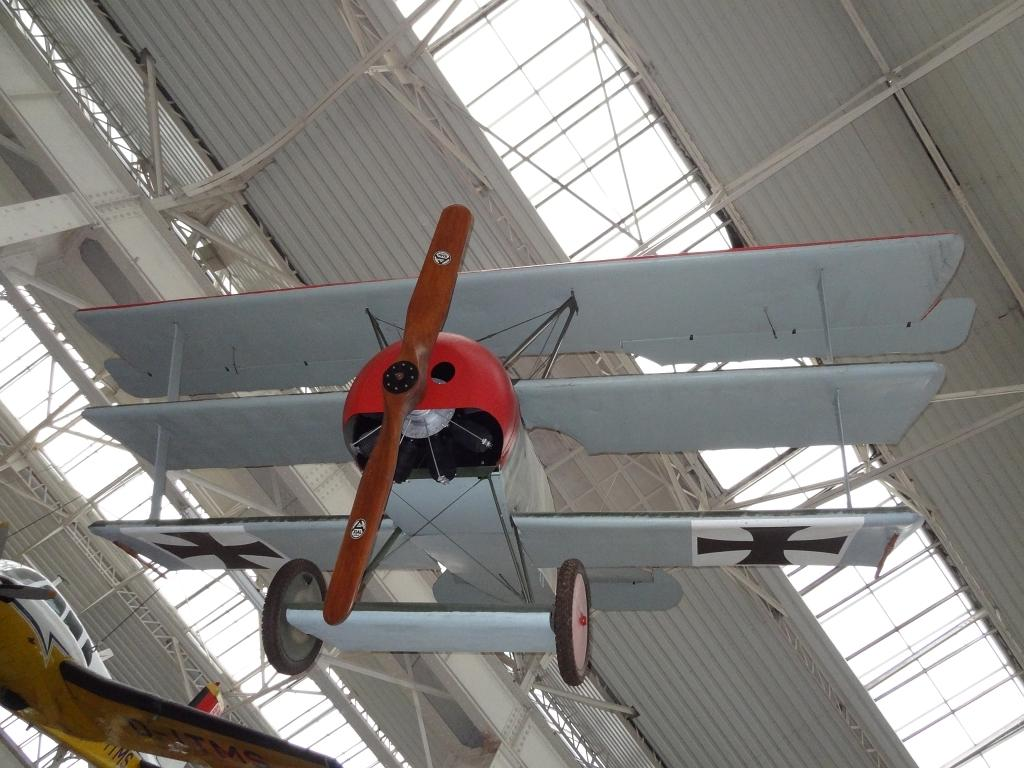How many airplanes are visible in the image? There are two airplanes in the image. What type of structure can be seen in the image? There is a metal shed in the image. How is the metal shed supported? The metal shed is supported by metal rod pillars. How many boats are visible in the image? There are no boats visible in the image; it only features two airplanes and a metal shed. Can you spot a crow perched on one of the airplanes in the image? There is no crow present in the image. 